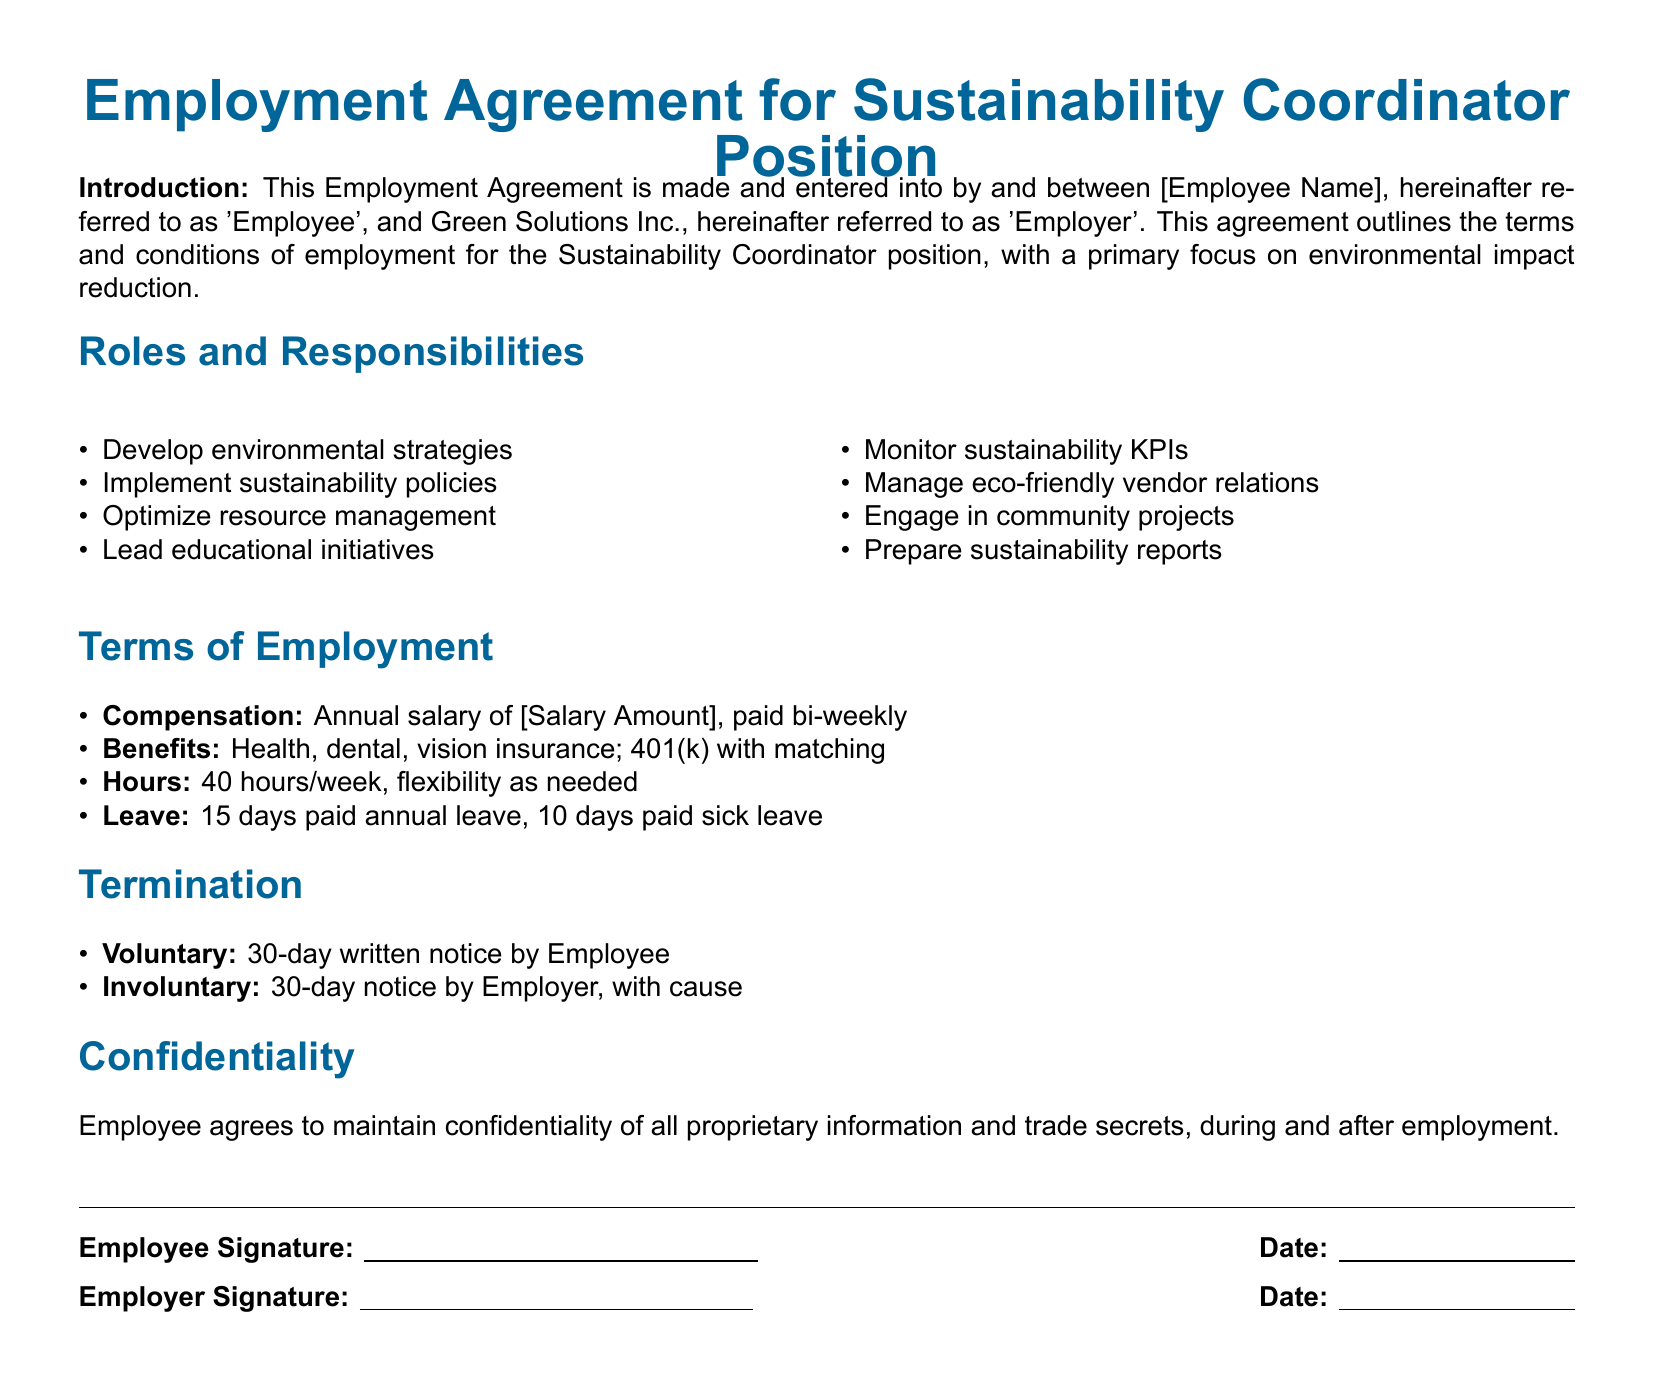what is the position title? The position title is clearly stated in the document's header as 'Sustainability Coordinator'.
Answer: Sustainability Coordinator what is the annual salary? The document indicates the salary amount will be filled in but does not specify an actual figure.
Answer: [Salary Amount] how many days of annual leave does the employee receive? The document states that the employee is entitled to 15 days of paid annual leave.
Answer: 15 days what is one responsibility of the Sustainability Coordinator? The document lists several responsibilities, such as developing environmental strategies.
Answer: Develop environmental strategies what type of insurance benefits are offered? The document lists multiple insurance benefits including health, dental, and vision insurance under benefits.
Answer: Health, dental, vision insurance how many hours per week is the employee expected to work? The document specifies that the employee will work 40 hours per week.
Answer: 40 hours/week what must the employee do to terminate the agreement voluntarily? The document requires a written notice of 30 days for voluntary termination.
Answer: 30-day written notice what is the notice period for involuntary termination by the employer? The document states a 30-day notice is required by the employer in case of involuntary termination.
Answer: 30-day notice how many paid sick leave days are provided? The document specifies that the employee will receive 10 days of paid sick leave.
Answer: 10 days 